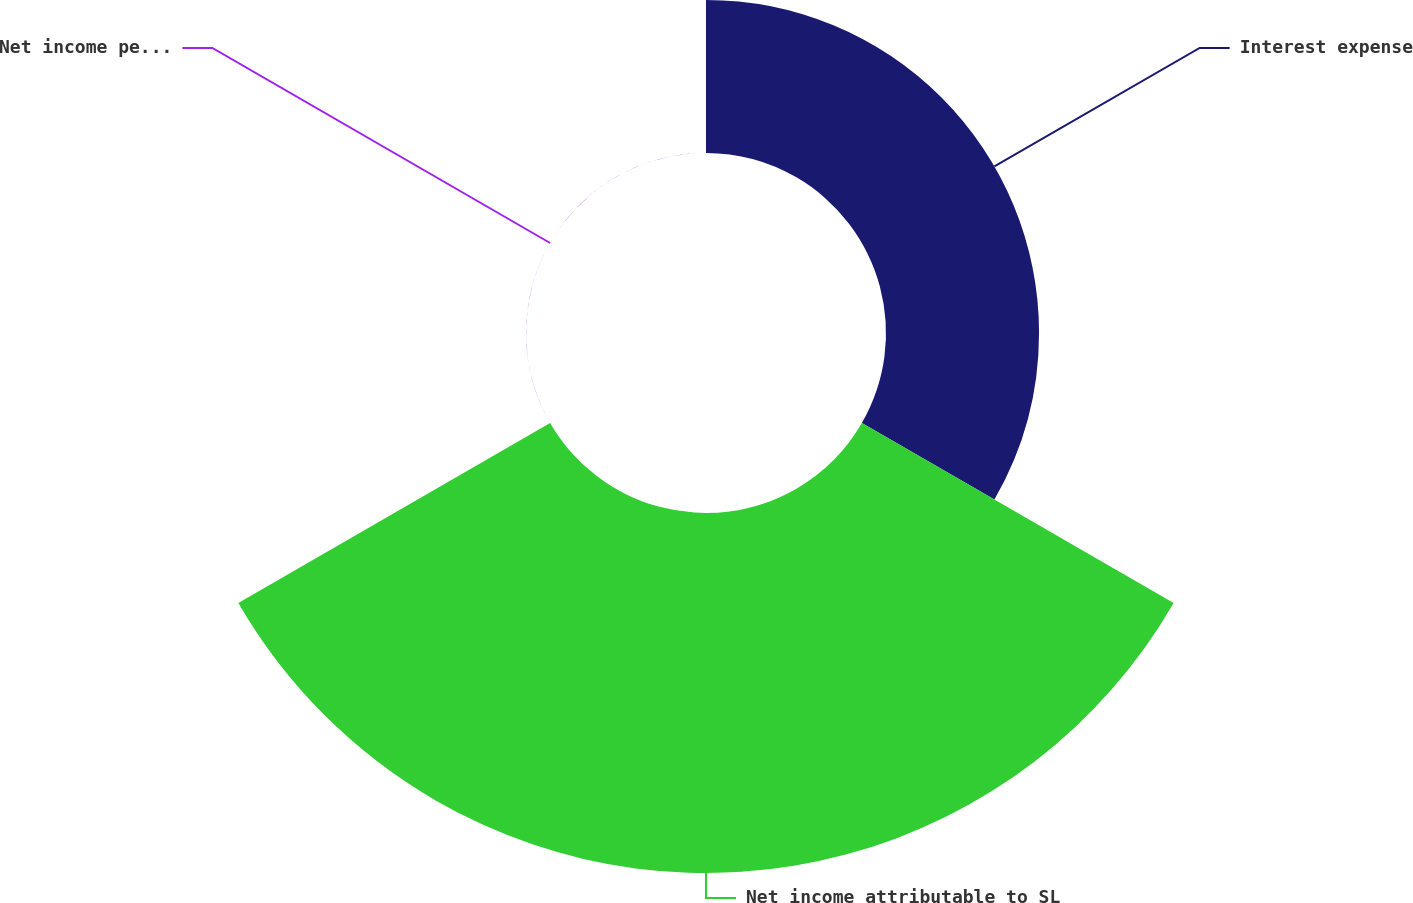Convert chart. <chart><loc_0><loc_0><loc_500><loc_500><pie_chart><fcel>Interest expense<fcel>Net income attributable to SL<fcel>Net income per share<nl><fcel>29.83%<fcel>70.17%<fcel>0.0%<nl></chart> 